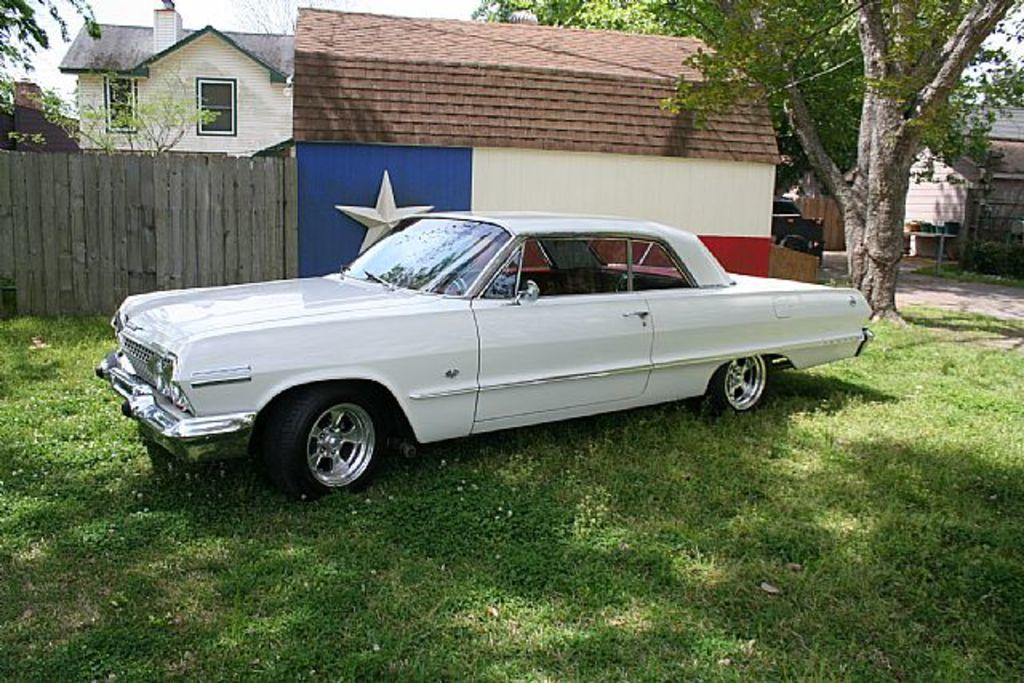What color is the car in the image? The car in the image is white. Where is the car located in the image? The car is on the ground. What can be seen in the background of the image? There is a building and trees in the background of the image. What type of vegetation is visible at the bottom of the image? There is grass visible at the bottom of the image. How does the car's mind influence its decision to park in the image? Cars do not have minds, so this question is not applicable to the image. 